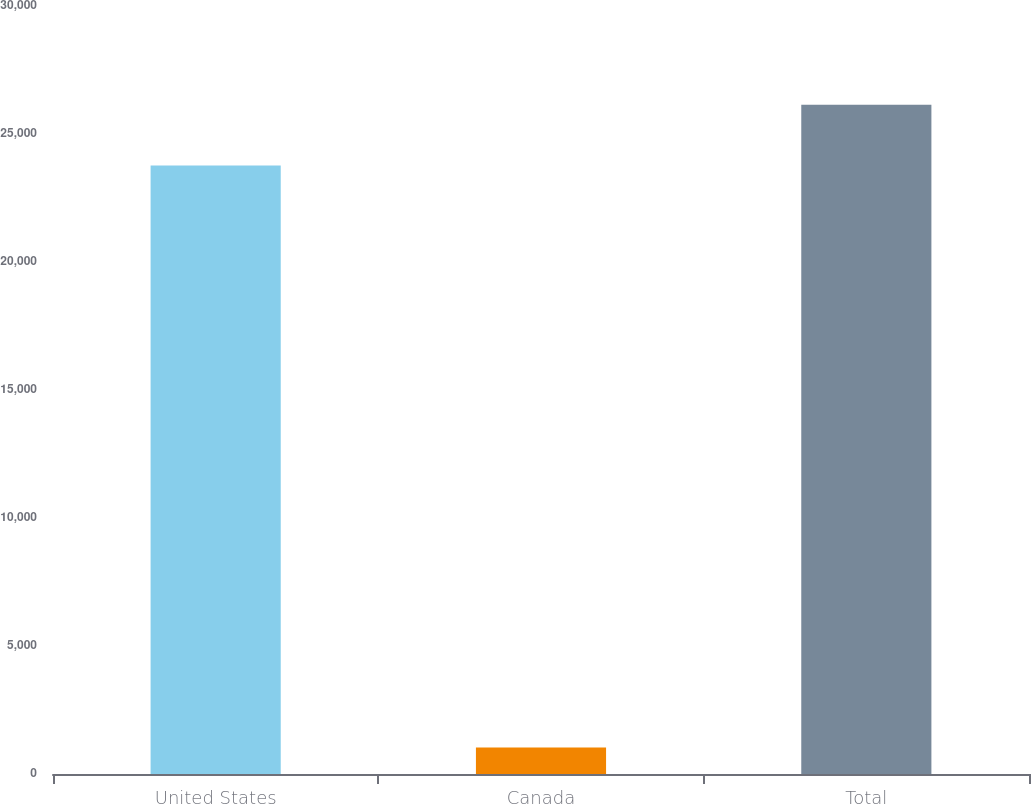<chart> <loc_0><loc_0><loc_500><loc_500><bar_chart><fcel>United States<fcel>Canada<fcel>Total<nl><fcel>23770<fcel>1031<fcel>26147<nl></chart> 